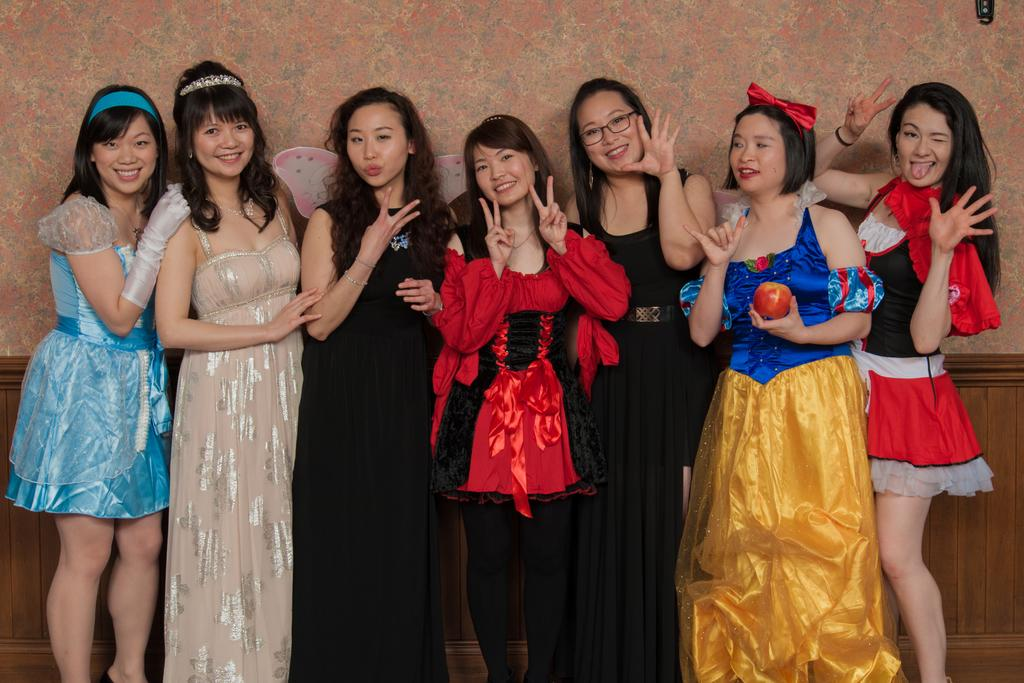What is the main subject of the image? The main subject of the image is a group of women. Where are the women located in the image? The women are standing in a place. What are the women doing in the image? The women are posing for a picture. What is the facial expression of the women in the image? The women are smiling. Can you see any dust in the image? There is no mention of dust in the provided facts, and therefore it cannot be determined if dust is present in the image. 